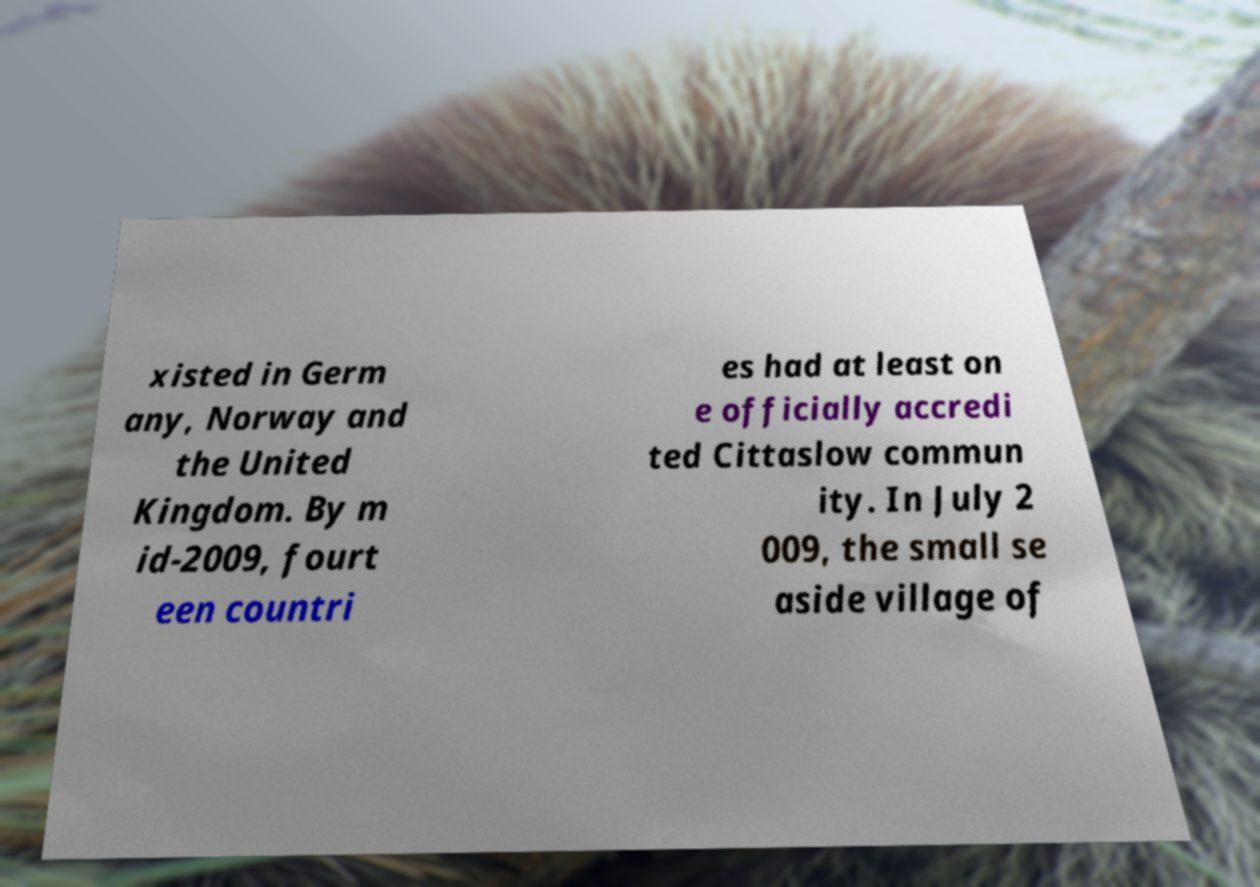I need the written content from this picture converted into text. Can you do that? xisted in Germ any, Norway and the United Kingdom. By m id-2009, fourt een countri es had at least on e officially accredi ted Cittaslow commun ity. In July 2 009, the small se aside village of 